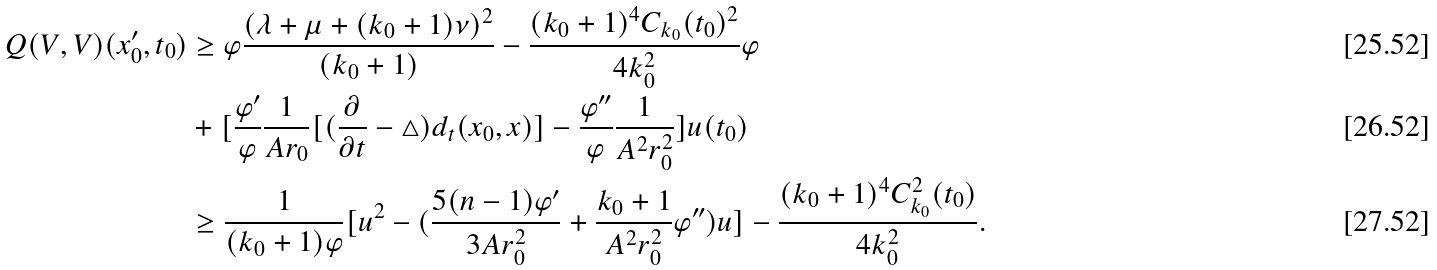Convert formula to latex. <formula><loc_0><loc_0><loc_500><loc_500>Q ( V , V ) ( x _ { 0 } ^ { \prime } , t _ { 0 } ) & \geq \varphi \frac { ( \lambda + \mu + ( k _ { 0 } + 1 ) \nu ) ^ { 2 } } { ( k _ { 0 } + 1 ) } - \frac { ( k _ { 0 } + 1 ) ^ { 4 } C _ { k _ { 0 } } ( t _ { 0 } ) ^ { 2 } } { 4 k _ { 0 } ^ { 2 } } \varphi \\ & + [ \frac { \varphi ^ { \prime } } { \varphi } \frac { 1 } { A r _ { 0 } } [ ( \frac { \partial } { \partial t } - \triangle ) d _ { t } ( x _ { 0 } , x ) ] - \frac { \varphi ^ { \prime \prime } } { \varphi } \frac { 1 } { A ^ { 2 } r _ { 0 } ^ { 2 } } ] u ( t _ { 0 } ) \\ & \geq \frac { 1 } { ( k _ { 0 } + 1 ) \varphi } [ u ^ { 2 } - ( \frac { 5 ( n - 1 ) \varphi ^ { \prime } } { 3 A r _ { 0 } ^ { 2 } } + \frac { k _ { 0 } + 1 } { A ^ { 2 } r _ { 0 } ^ { 2 } } \varphi ^ { \prime \prime } ) u ] - \frac { ( k _ { 0 } + 1 ) ^ { 4 } C _ { k _ { 0 } } ^ { 2 } ( t _ { 0 } ) } { 4 k _ { 0 } ^ { 2 } } .</formula> 